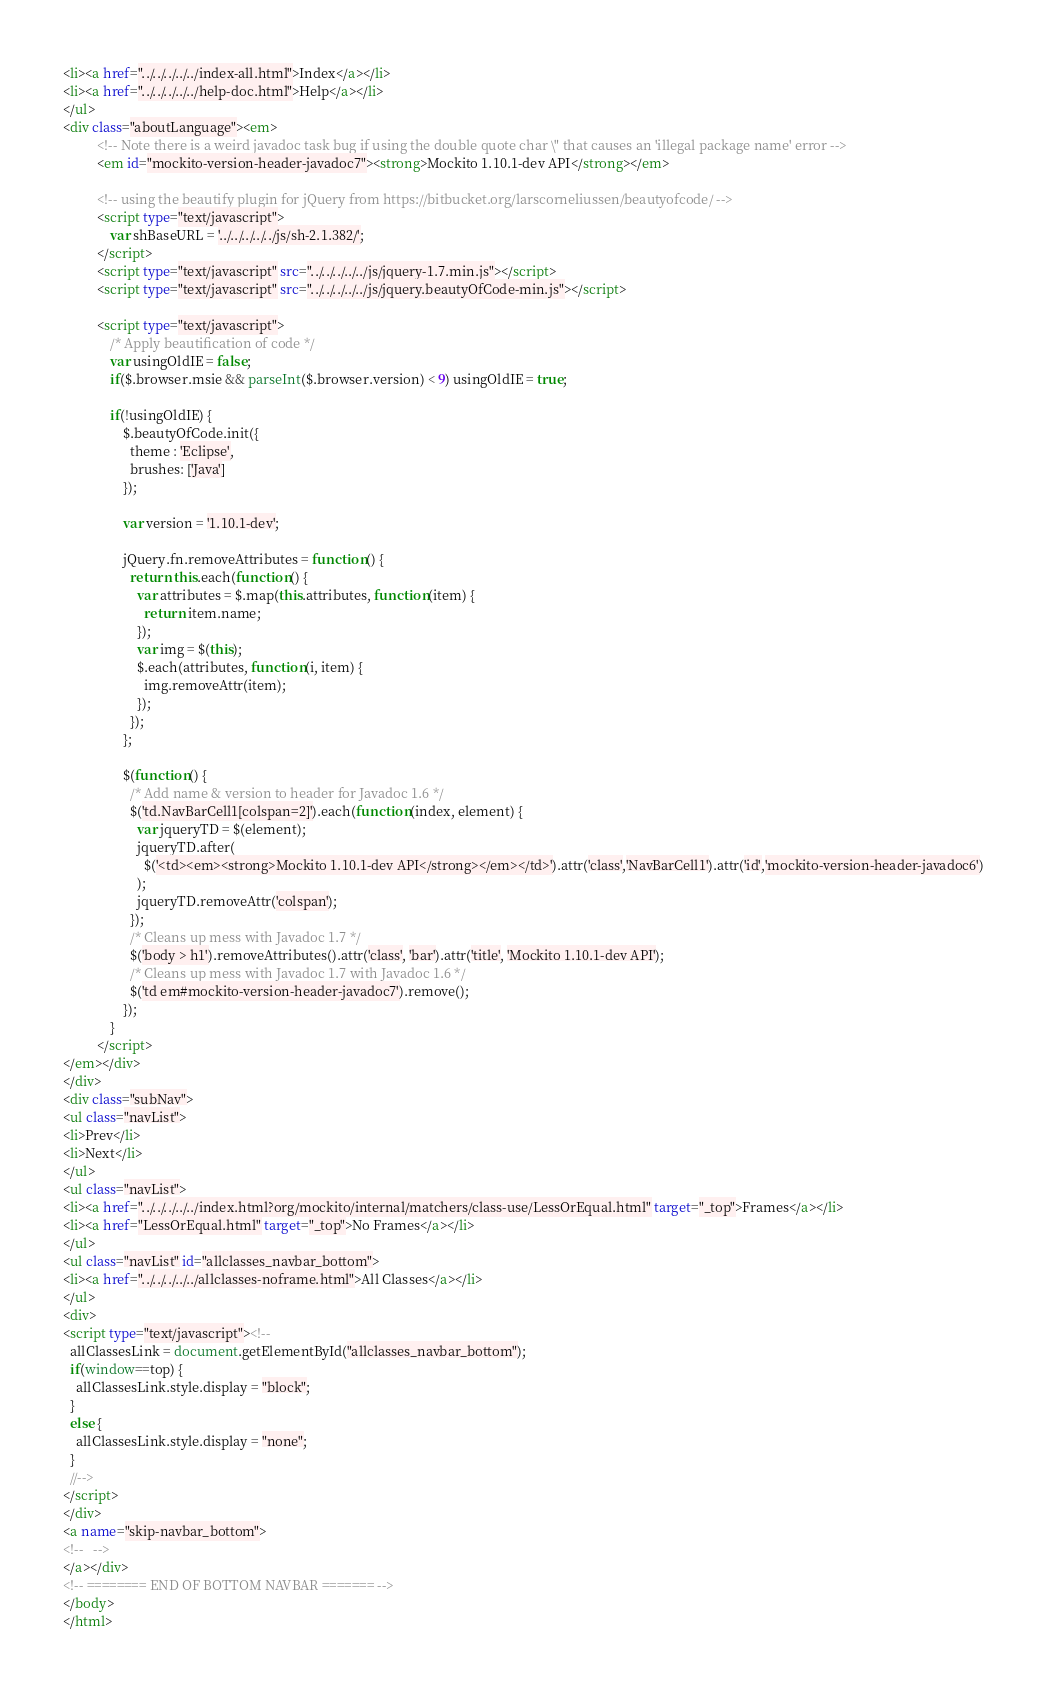<code> <loc_0><loc_0><loc_500><loc_500><_HTML_><li><a href="../../../../../index-all.html">Index</a></li>
<li><a href="../../../../../help-doc.html">Help</a></li>
</ul>
<div class="aboutLanguage"><em>
          <!-- Note there is a weird javadoc task bug if using the double quote char \" that causes an 'illegal package name' error -->
          <em id="mockito-version-header-javadoc7"><strong>Mockito 1.10.1-dev API</strong></em>

          <!-- using the beautify plugin for jQuery from https://bitbucket.org/larscorneliussen/beautyofcode/ -->
          <script type="text/javascript">
              var shBaseURL = '../../../../../js/sh-2.1.382/';
          </script>
          <script type="text/javascript" src="../../../../../js/jquery-1.7.min.js"></script>
          <script type="text/javascript" src="../../../../../js/jquery.beautyOfCode-min.js"></script>

          <script type="text/javascript">
              /* Apply beautification of code */
              var usingOldIE = false;
              if($.browser.msie && parseInt($.browser.version) < 9) usingOldIE = true;

              if(!usingOldIE) {
                  $.beautyOfCode.init({
                    theme : 'Eclipse',
                    brushes: ['Java']
                  });

                  var version = '1.10.1-dev';

                  jQuery.fn.removeAttributes = function() {
                    return this.each(function() {
                      var attributes = $.map(this.attributes, function(item) {
                        return item.name;
                      });
                      var img = $(this);
                      $.each(attributes, function(i, item) {
                        img.removeAttr(item);
                      });
                    });
                  };

                  $(function() {
                    /* Add name & version to header for Javadoc 1.6 */
                    $('td.NavBarCell1[colspan=2]').each(function(index, element) {
                      var jqueryTD = $(element);
                      jqueryTD.after(
                        $('<td><em><strong>Mockito 1.10.1-dev API</strong></em></td>').attr('class','NavBarCell1').attr('id','mockito-version-header-javadoc6')
                      );
                      jqueryTD.removeAttr('colspan');
                    });
                    /* Cleans up mess with Javadoc 1.7 */
                    $('body > h1').removeAttributes().attr('class', 'bar').attr('title', 'Mockito 1.10.1-dev API');
                    /* Cleans up mess with Javadoc 1.7 with Javadoc 1.6 */
                    $('td em#mockito-version-header-javadoc7').remove();
                  });
              }
          </script>
</em></div>
</div>
<div class="subNav">
<ul class="navList">
<li>Prev</li>
<li>Next</li>
</ul>
<ul class="navList">
<li><a href="../../../../../index.html?org/mockito/internal/matchers/class-use/LessOrEqual.html" target="_top">Frames</a></li>
<li><a href="LessOrEqual.html" target="_top">No Frames</a></li>
</ul>
<ul class="navList" id="allclasses_navbar_bottom">
<li><a href="../../../../../allclasses-noframe.html">All Classes</a></li>
</ul>
<div>
<script type="text/javascript"><!--
  allClassesLink = document.getElementById("allclasses_navbar_bottom");
  if(window==top) {
    allClassesLink.style.display = "block";
  }
  else {
    allClassesLink.style.display = "none";
  }
  //-->
</script>
</div>
<a name="skip-navbar_bottom">
<!--   -->
</a></div>
<!-- ======== END OF BOTTOM NAVBAR ======= -->
</body>
</html>
</code> 